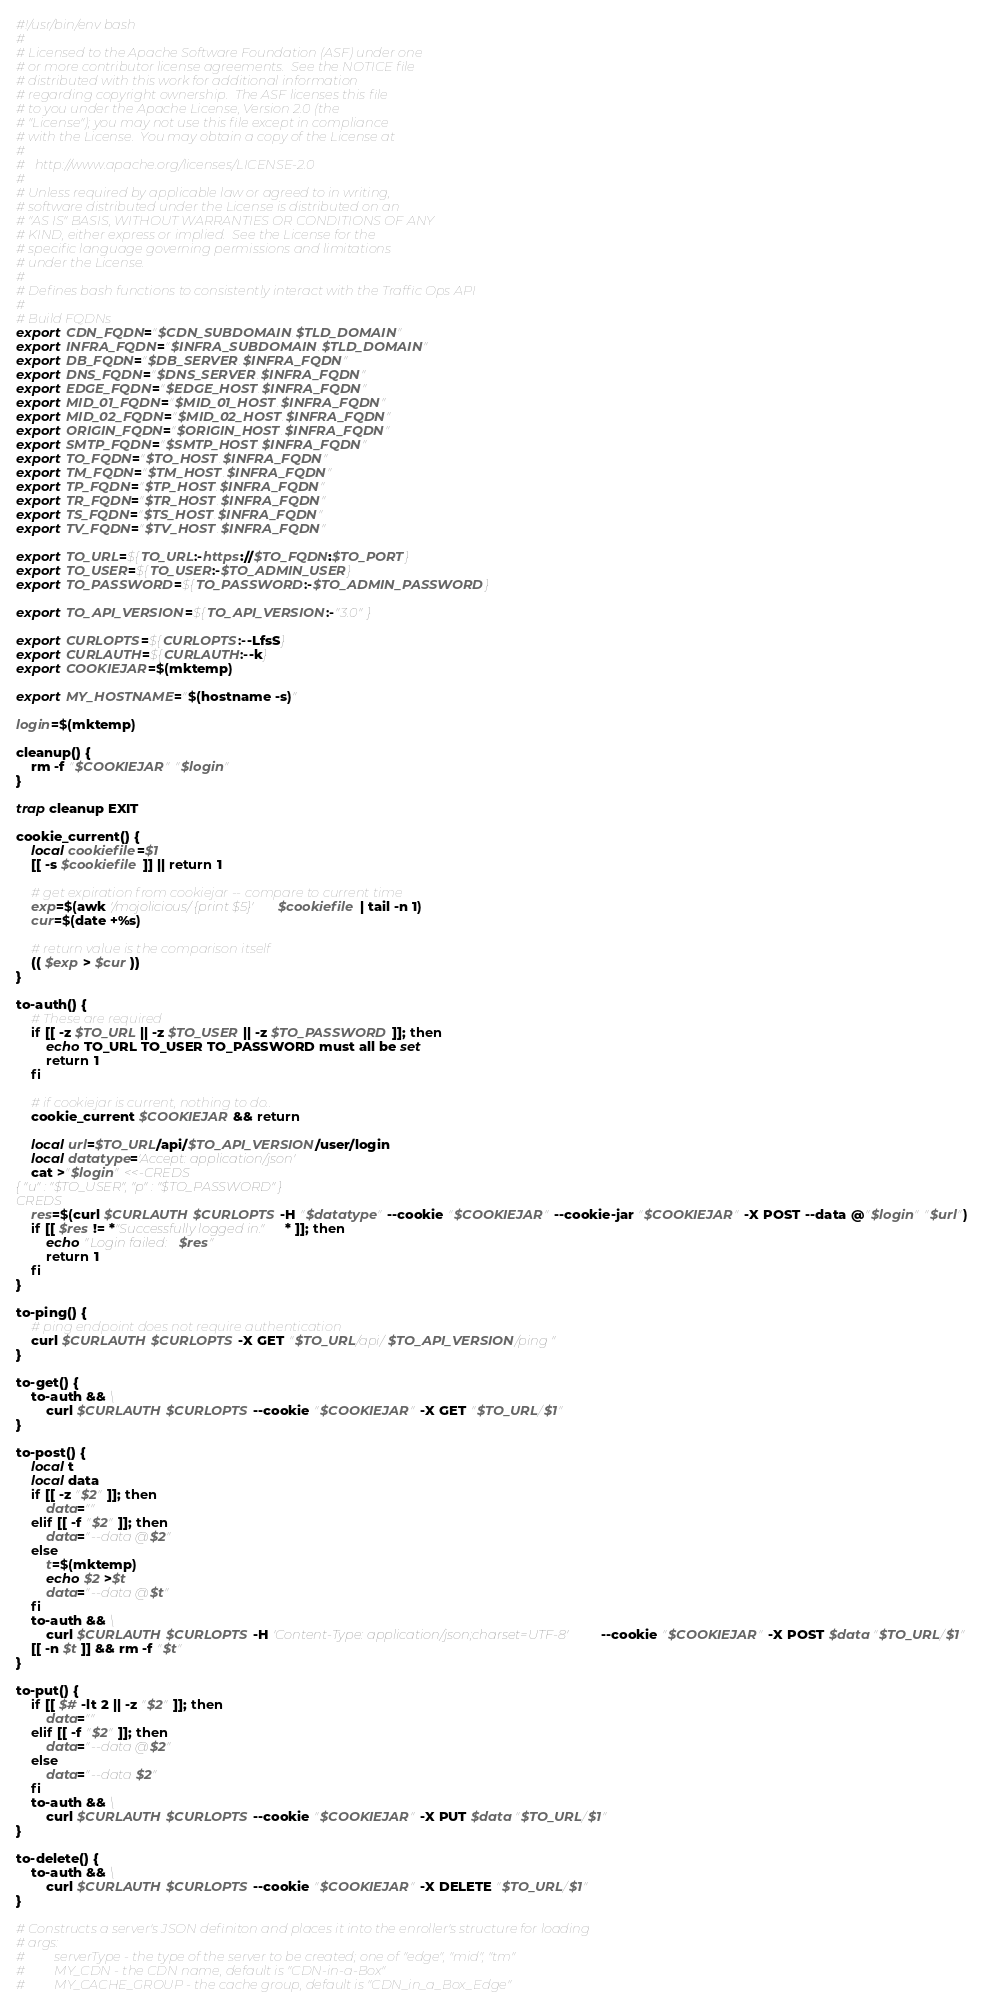<code> <loc_0><loc_0><loc_500><loc_500><_Bash_>#!/usr/bin/env bash
#
# Licensed to the Apache Software Foundation (ASF) under one
# or more contributor license agreements.  See the NOTICE file
# distributed with this work for additional information
# regarding copyright ownership.  The ASF licenses this file
# to you under the Apache License, Version 2.0 (the
# "License"); you may not use this file except in compliance
# with the License.  You may obtain a copy of the License at
#
#   http://www.apache.org/licenses/LICENSE-2.0
#
# Unless required by applicable law or agreed to in writing,
# software distributed under the License is distributed on an
# "AS IS" BASIS, WITHOUT WARRANTIES OR CONDITIONS OF ANY
# KIND, either express or implied.  See the License for the
# specific language governing permissions and limitations
# under the License.
#
# Defines bash functions to consistently interact with the Traffic Ops API
#
# Build FQDNs
export CDN_FQDN="$CDN_SUBDOMAIN.$TLD_DOMAIN"
export INFRA_FQDN="$INFRA_SUBDOMAIN.$TLD_DOMAIN"
export DB_FQDN="$DB_SERVER.$INFRA_FQDN"
export DNS_FQDN="$DNS_SERVER.$INFRA_FQDN"
export EDGE_FQDN="$EDGE_HOST.$INFRA_FQDN"
export MID_01_FQDN="$MID_01_HOST.$INFRA_FQDN"
export MID_02_FQDN="$MID_02_HOST.$INFRA_FQDN"
export ORIGIN_FQDN="$ORIGIN_HOST.$INFRA_FQDN"
export SMTP_FQDN="$SMTP_HOST.$INFRA_FQDN"
export TO_FQDN="$TO_HOST.$INFRA_FQDN"
export TM_FQDN="$TM_HOST.$INFRA_FQDN"
export TP_FQDN="$TP_HOST.$INFRA_FQDN"
export TR_FQDN="$TR_HOST.$INFRA_FQDN"
export TS_FQDN="$TS_HOST.$INFRA_FQDN"
export TV_FQDN="$TV_HOST.$INFRA_FQDN"

export TO_URL=${TO_URL:-https://$TO_FQDN:$TO_PORT}
export TO_USER=${TO_USER:-$TO_ADMIN_USER}
export TO_PASSWORD=${TO_PASSWORD:-$TO_ADMIN_PASSWORD}

export TO_API_VERSION=${TO_API_VERSION:-"3.0"}

export CURLOPTS=${CURLOPTS:--LfsS}
export CURLAUTH=${CURLAUTH:--k}
export COOKIEJAR=$(mktemp)

export MY_HOSTNAME="$(hostname -s)"

login=$(mktemp)

cleanup() {
	rm -f "$COOKIEJAR" "$login"
}

trap cleanup EXIT

cookie_current() {
	local cookiefile=$1
	[[ -s $cookiefile ]] || return 1

	# get expiration from cookiejar -- compare to current time
	exp=$(awk '/mojolicious/ {print $5}' $cookiefile | tail -n 1)
	cur=$(date +%s)

	# return value is the comparison itself
	(( $exp > $cur ))
}

to-auth() {
	# These are required
	if [[ -z $TO_URL || -z $TO_USER || -z $TO_PASSWORD ]]; then
		echo TO_URL TO_USER TO_PASSWORD must all be set
		return 1
	fi

	# if cookiejar is current, nothing to do..
	cookie_current $COOKIEJAR && return

	local url=$TO_URL/api/$TO_API_VERSION/user/login
	local datatype='Accept: application/json'
	cat >"$login" <<-CREDS
{ "u" : "$TO_USER", "p" : "$TO_PASSWORD" }
CREDS
	res=$(curl $CURLAUTH $CURLOPTS -H "$datatype" --cookie "$COOKIEJAR" --cookie-jar "$COOKIEJAR" -X POST --data @"$login" "$url")
	if [[ $res != *"Successfully logged in."* ]]; then
		echo "Login failed: $res"
		return 1
	fi
}

to-ping() {
	# ping endpoint does not require authentication
	curl $CURLAUTH $CURLOPTS -X GET "$TO_URL/api/$TO_API_VERSION/ping"
}

to-get() {
	to-auth && \
		curl $CURLAUTH $CURLOPTS --cookie "$COOKIEJAR" -X GET "$TO_URL/$1"
}

to-post() {
	local t
	local data
	if [[ -z "$2" ]]; then
		data=""
	elif [[ -f "$2" ]]; then
		data="--data @$2"
	else
		t=$(mktemp)
		echo $2 >$t
		data="--data @$t"
	fi
	to-auth && \
	    curl $CURLAUTH $CURLOPTS -H 'Content-Type: application/json;charset=UTF-8' --cookie "$COOKIEJAR" -X POST $data "$TO_URL/$1"
	[[ -n $t ]] && rm -f "$t"
}

to-put() {
	if [[ $# -lt 2 || -z "$2" ]]; then
		data=""
	elif [[ -f "$2" ]]; then
		data="--data @$2"
	else
		data="--data $2"
	fi
	to-auth && \
	    curl $CURLAUTH $CURLOPTS --cookie "$COOKIEJAR" -X PUT $data "$TO_URL/$1"
}

to-delete() {
	to-auth && \
		curl $CURLAUTH $CURLOPTS --cookie "$COOKIEJAR" -X DELETE "$TO_URL/$1"
}

# Constructs a server's JSON definiton and places it into the enroller's structure for loading
# args:
#         serverType - the type of the server to be created; one of "edge", "mid", "tm"
#         MY_CDN - the CDN name, default is "CDN-in-a-Box"
#         MY_CACHE_GROUP - the cache group, default is "CDN_in_a_Box_Edge"</code> 